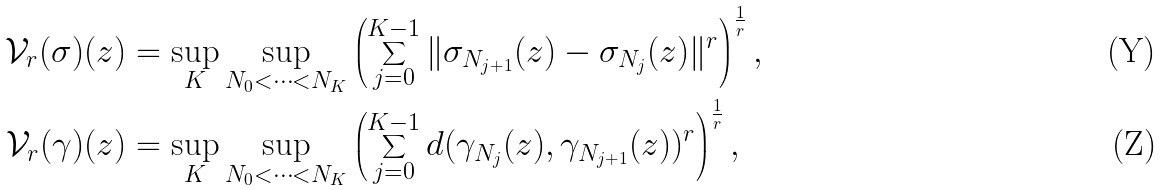Convert formula to latex. <formula><loc_0><loc_0><loc_500><loc_500>\mathcal { V } _ { r } ( \sigma ) ( z ) & = \sup _ { K } \sup _ { N _ { 0 } < \dots < N _ { K } } \left ( \sum _ { j = 0 } ^ { K - 1 } \| \sigma _ { N _ { j + 1 } } ( z ) - \sigma _ { N _ { j } } ( z ) \| ^ { r } \right ) ^ { \frac { 1 } { r } } , \\ \mathcal { V } _ { r } ( \gamma ) ( z ) & = \sup _ { K } \sup _ { N _ { 0 } < \dots < N _ { K } } \left ( \sum _ { j = 0 } ^ { K - 1 } d ( \gamma _ { N _ { j } } ( z ) , \gamma _ { N _ { j + 1 } } ( z ) ) ^ { r } \right ) ^ { \frac { 1 } { r } } ,</formula> 